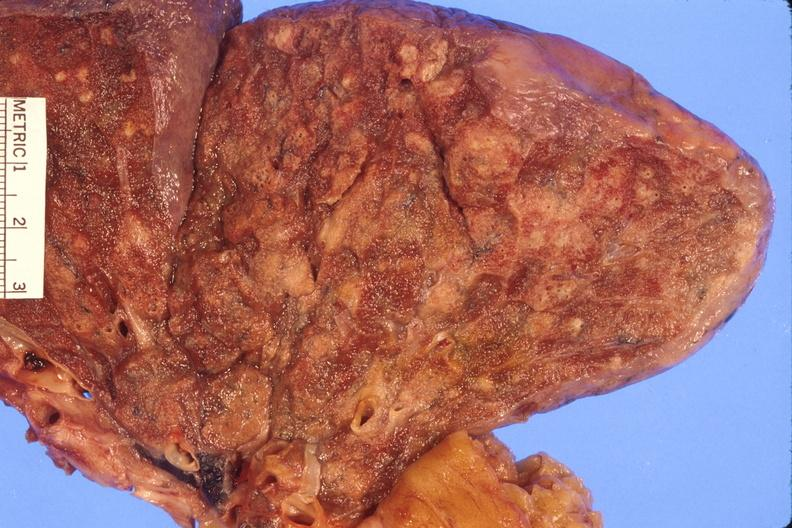does palmar crease normal show lung, abscess?
Answer the question using a single word or phrase. No 